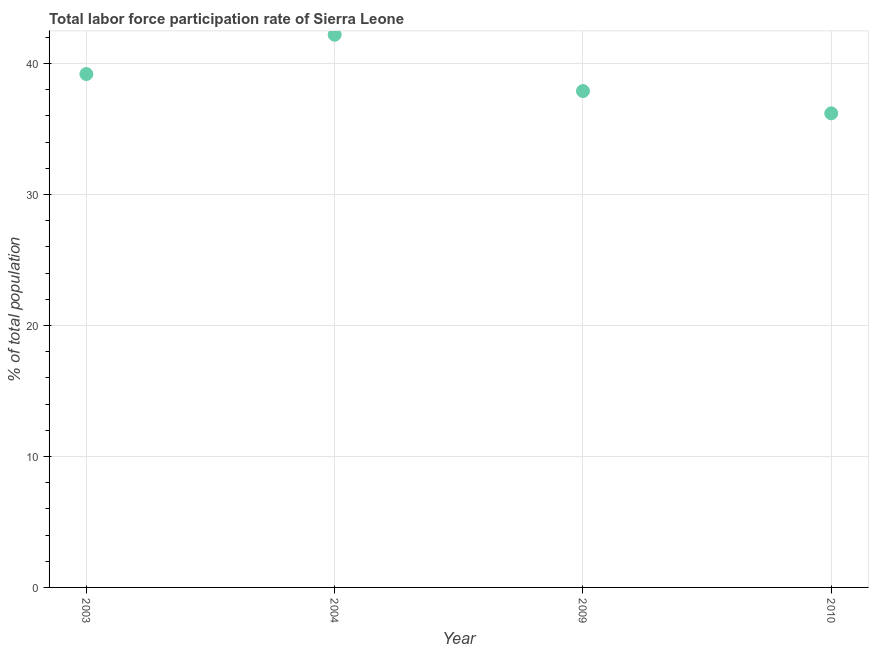What is the total labor force participation rate in 2004?
Provide a succinct answer. 42.2. Across all years, what is the maximum total labor force participation rate?
Your answer should be compact. 42.2. Across all years, what is the minimum total labor force participation rate?
Your response must be concise. 36.2. In which year was the total labor force participation rate minimum?
Your answer should be compact. 2010. What is the sum of the total labor force participation rate?
Offer a terse response. 155.5. What is the average total labor force participation rate per year?
Ensure brevity in your answer.  38.88. What is the median total labor force participation rate?
Keep it short and to the point. 38.55. What is the ratio of the total labor force participation rate in 2003 to that in 2010?
Offer a terse response. 1.08. Is the total labor force participation rate in 2003 less than that in 2010?
Ensure brevity in your answer.  No. Is the sum of the total labor force participation rate in 2003 and 2004 greater than the maximum total labor force participation rate across all years?
Keep it short and to the point. Yes. In how many years, is the total labor force participation rate greater than the average total labor force participation rate taken over all years?
Ensure brevity in your answer.  2. Are the values on the major ticks of Y-axis written in scientific E-notation?
Your response must be concise. No. Does the graph contain any zero values?
Give a very brief answer. No. What is the title of the graph?
Make the answer very short. Total labor force participation rate of Sierra Leone. What is the label or title of the Y-axis?
Ensure brevity in your answer.  % of total population. What is the % of total population in 2003?
Offer a very short reply. 39.2. What is the % of total population in 2004?
Your response must be concise. 42.2. What is the % of total population in 2009?
Keep it short and to the point. 37.9. What is the % of total population in 2010?
Your answer should be compact. 36.2. What is the difference between the % of total population in 2003 and 2004?
Ensure brevity in your answer.  -3. What is the difference between the % of total population in 2003 and 2009?
Give a very brief answer. 1.3. What is the difference between the % of total population in 2004 and 2010?
Provide a succinct answer. 6. What is the ratio of the % of total population in 2003 to that in 2004?
Keep it short and to the point. 0.93. What is the ratio of the % of total population in 2003 to that in 2009?
Offer a terse response. 1.03. What is the ratio of the % of total population in 2003 to that in 2010?
Ensure brevity in your answer.  1.08. What is the ratio of the % of total population in 2004 to that in 2009?
Provide a short and direct response. 1.11. What is the ratio of the % of total population in 2004 to that in 2010?
Offer a terse response. 1.17. What is the ratio of the % of total population in 2009 to that in 2010?
Provide a succinct answer. 1.05. 